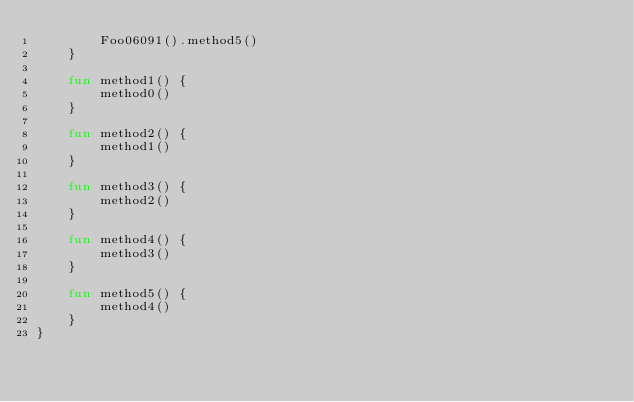<code> <loc_0><loc_0><loc_500><loc_500><_Kotlin_>        Foo06091().method5()
    }

    fun method1() {
        method0()
    }

    fun method2() {
        method1()
    }

    fun method3() {
        method2()
    }

    fun method4() {
        method3()
    }

    fun method5() {
        method4()
    }
}
</code> 